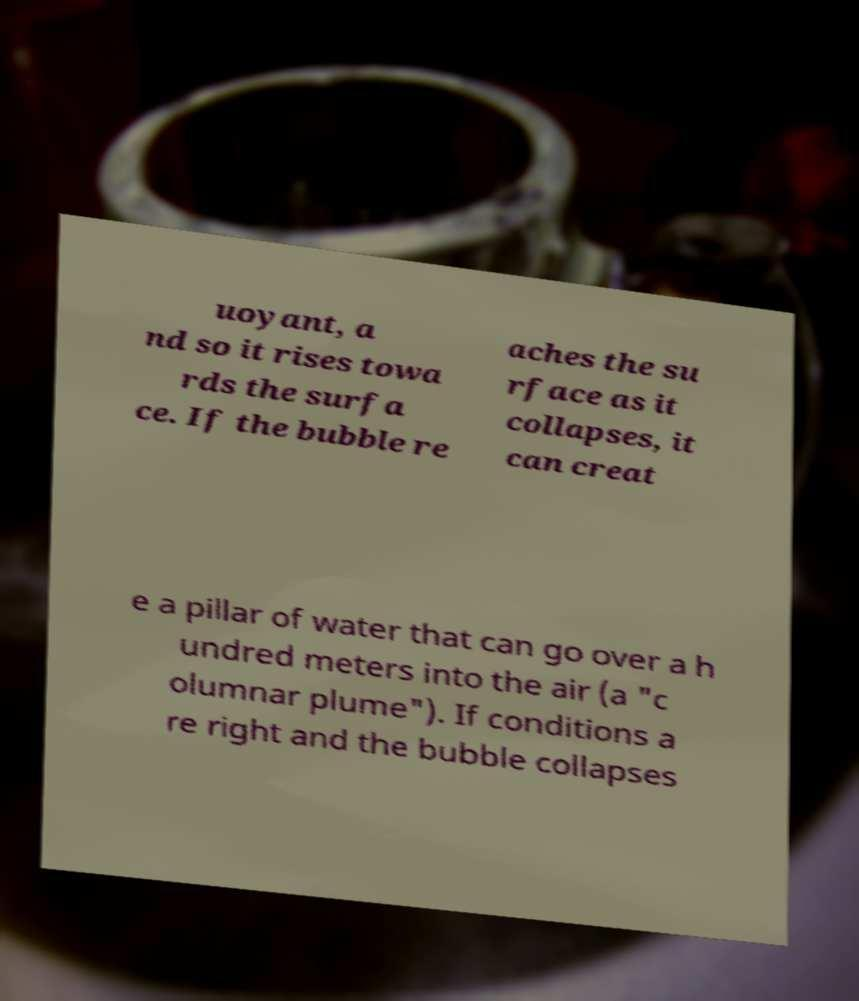Can you accurately transcribe the text from the provided image for me? uoyant, a nd so it rises towa rds the surfa ce. If the bubble re aches the su rface as it collapses, it can creat e a pillar of water that can go over a h undred meters into the air (a "c olumnar plume"). If conditions a re right and the bubble collapses 